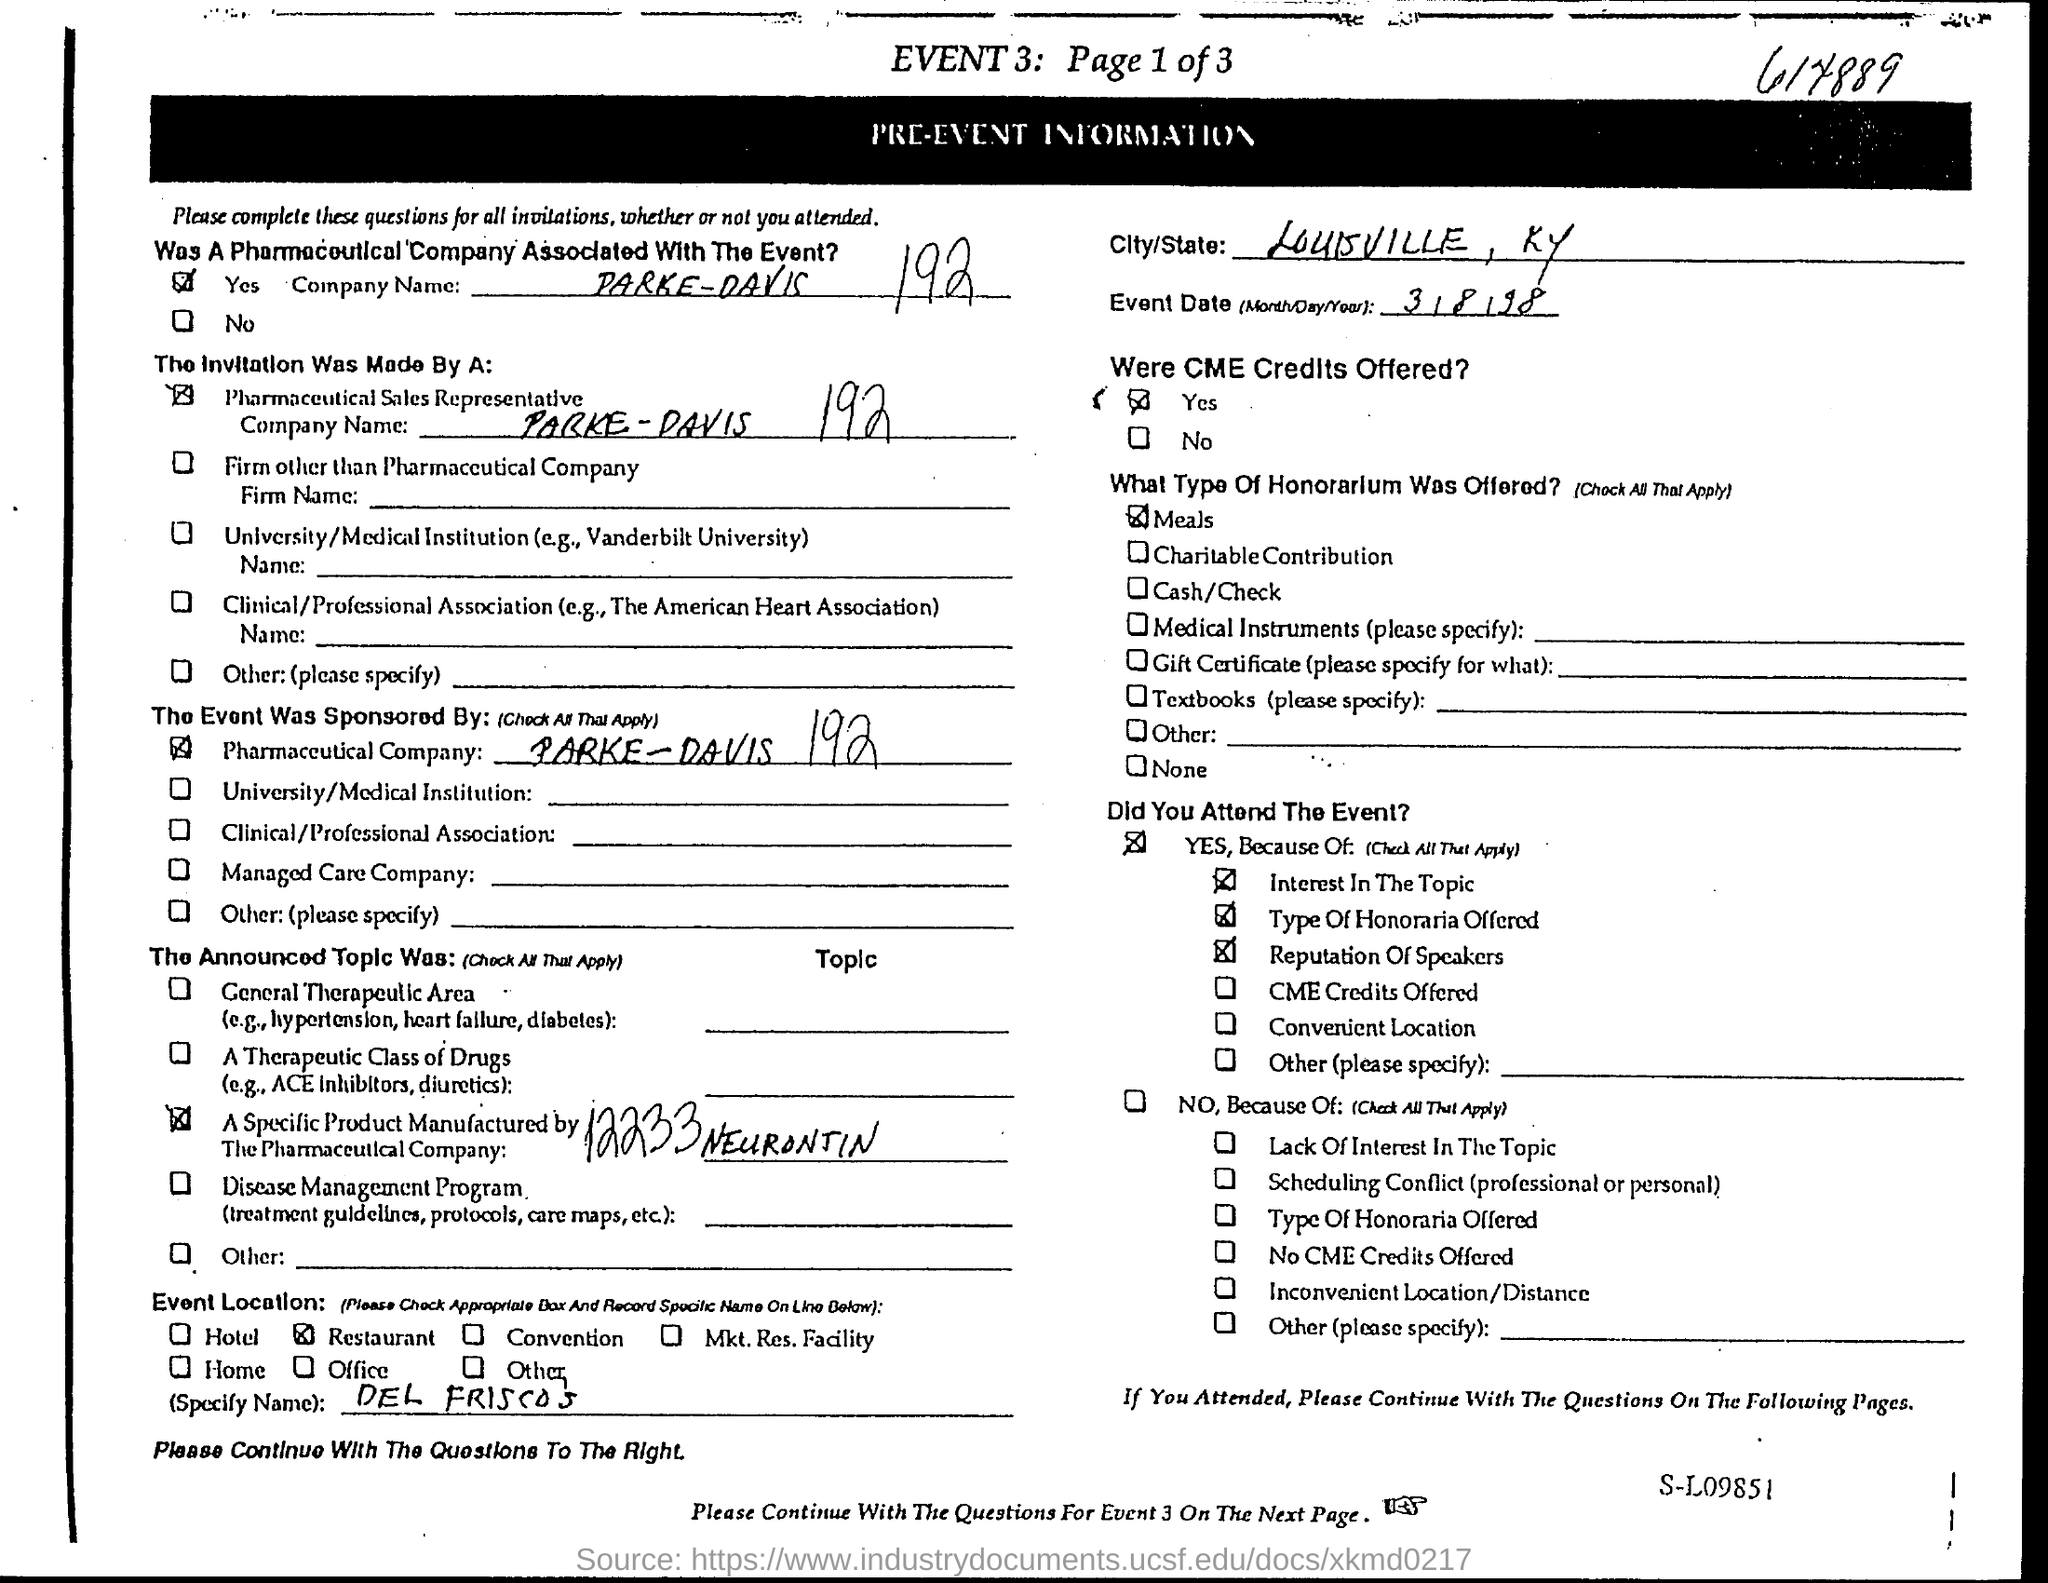When is the event date?
Provide a succinct answer. 3/8/98. What type of honorarium was offered?
Make the answer very short. Meals. Which is the City/State?
Ensure brevity in your answer.  LOUISVILLE, KY. 